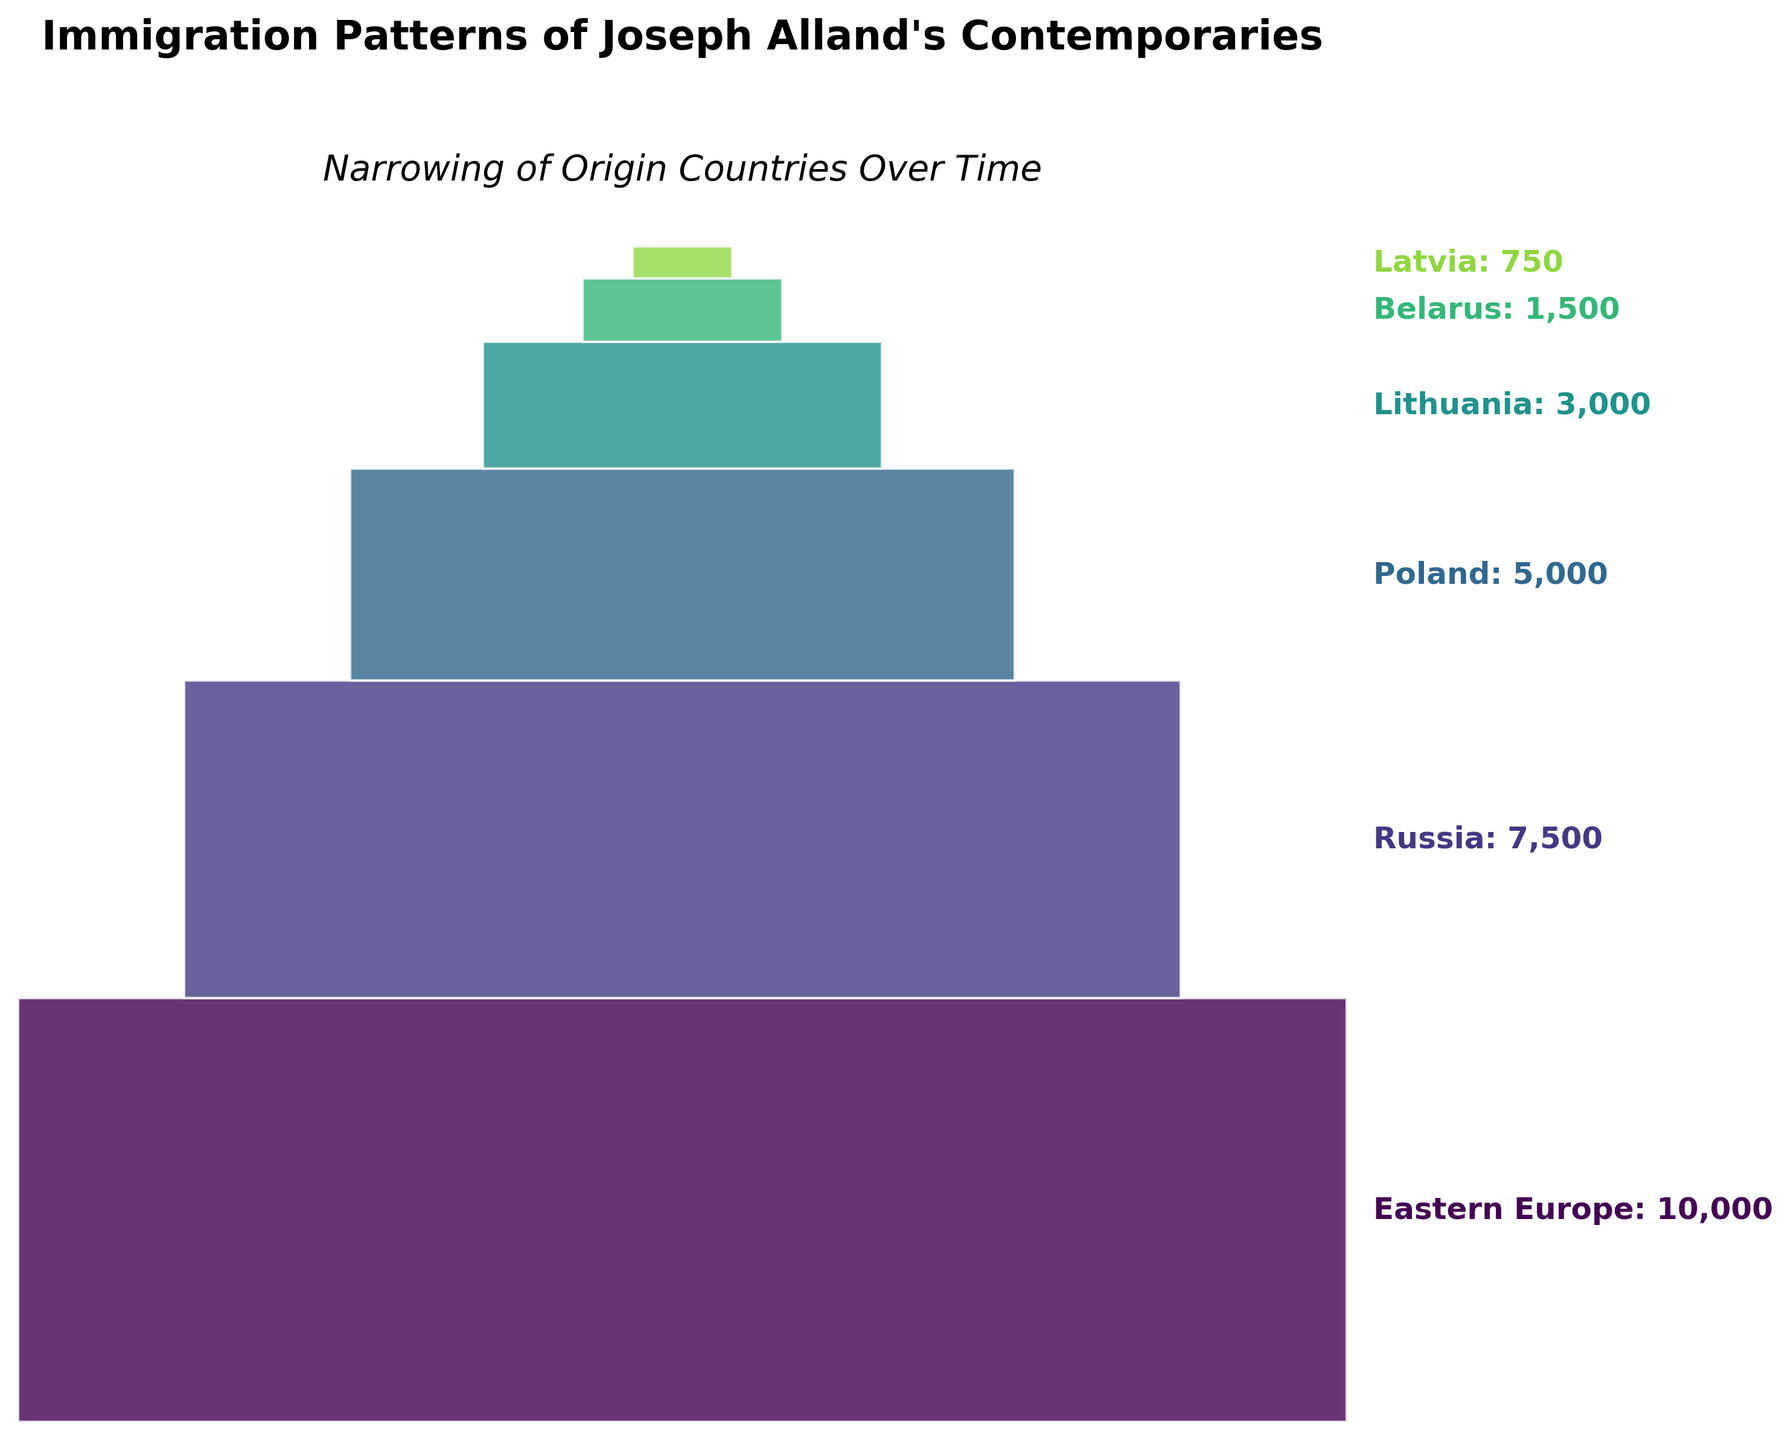what is the title of the chart? The title is displayed prominently at the top of the chart. It reads "Immigration Patterns of Joseph Alland's Contemporaries," indicating the subject of the visualization.
Answer: Immigration Patterns of Joseph Alland's Contemporaries which country had the highest number of immigrants? The highest section in the funnel chart is at the top, representing the country with the most immigrants. The label next to this top section reads "Eastern Europe: 10,000".
Answer: Eastern Europe which two countries contributed the fewest number of immigrants? The bottom two sections of the funnel chart represent the countries with the smallest immigrant numbers. They are labeled "Belarus: 1,500" and "Latvia: 750."
Answer: Belarus and Latvia how does the number of immigrants from Poland compare to those from Lithuania? The height of the segment for Poland is clearly taller than that for Lithuania. The labels read "Poland: 5,000" and "Lithuania: 3,000," indicating Poland had more immigrants than Lithuania.
Answer: Poland has more immigrants than Lithuania what is the total number of immigrants from Eastern Europe, Russia, and Poland combined? The immigration numbers for these countries are given in the chart as Eastern Europe: 10,000, Russia: 7,500, and Poland: 5,000. Adding these values together gives 10,000 + 7,500 + 5,000 = 22,500.
Answer: 22,500 what proportion of the total immigrants came from Belarus? First, calculate the total number of immigrants by summing the values for all countries: 10,000 (Eastern Europe) + 7,500 (Russia) + 5,000 (Poland) + 3,000 (Lithuania) + 1,500 (Belarus) + 750 (Latvia) = 27,750. Then, find the proportion of Belarus immigrants by dividing 1,500 by 27,750 and multiplying by 100 for the percentage (1,500 / 27,750 * 100 ≈ 5.41%).
Answer: Approximately 5.41% which funnel segment has the largest difference in width compared to the previous segment? Observing the widths of the segments visually, the largest change occurs between the "Russia: 7,500" segment and the "Eastern Europe: 10,000" segment. The width notably narrows between these two sections.
Answer: The segment between Eastern Europe and Russia if the countries are grouped into Eastern Europe (Eastern Europe, Russia, Poland) and Baltic (Lithuania, Belarus, Latvia), which group had more immigrants in total? Summing up the immigrant numbers for the Eastern Europe group (Eastern Europe: 10,000, Russia: 7,500, Poland: 5,000) gives 10,000 + 7,500 + 5,000 = 22,500. Summing for the Baltic group (Lithuania: 3,000, Belarus: 1,500, Latvia: 750) gives 3,000 + 1,500 + 750 = 5,250. Comparing these sums shows Eastern Europe had more immigrants.
Answer: Eastern Europe group had more immigrants 